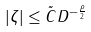Convert formula to latex. <formula><loc_0><loc_0><loc_500><loc_500>| \zeta | \leq \tilde { C } D ^ { - \frac { \rho } { 2 } }</formula> 